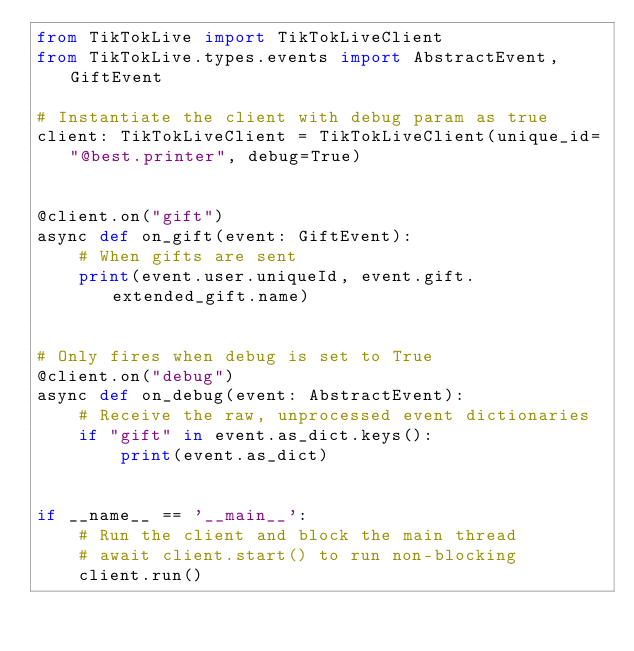Convert code to text. <code><loc_0><loc_0><loc_500><loc_500><_Python_>from TikTokLive import TikTokLiveClient
from TikTokLive.types.events import AbstractEvent, GiftEvent

# Instantiate the client with debug param as true
client: TikTokLiveClient = TikTokLiveClient(unique_id="@best.printer", debug=True)


@client.on("gift")
async def on_gift(event: GiftEvent):
    # When gifts are sent
    print(event.user.uniqueId, event.gift.extended_gift.name)


# Only fires when debug is set to True
@client.on("debug")
async def on_debug(event: AbstractEvent):
    # Receive the raw, unprocessed event dictionaries
    if "gift" in event.as_dict.keys():
        print(event.as_dict)


if __name__ == '__main__':
    # Run the client and block the main thread
    # await client.start() to run non-blocking
    client.run()
</code> 